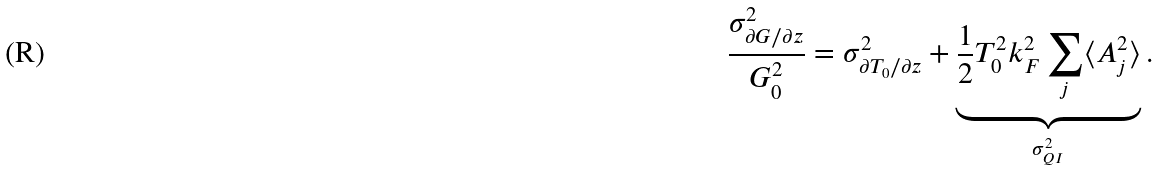Convert formula to latex. <formula><loc_0><loc_0><loc_500><loc_500>\frac { \sigma ^ { 2 } _ { \partial G / \partial z } } { G ^ { 2 } _ { 0 } } = \sigma ^ { 2 } _ { \partial T _ { 0 } / \partial z } + \underbrace { \frac { 1 } { 2 } T ^ { 2 } _ { 0 } k ^ { 2 } _ { F } \sum _ { j } \langle A ^ { 2 } _ { j } \rangle } _ { \sigma ^ { 2 } _ { Q I } } .</formula> 